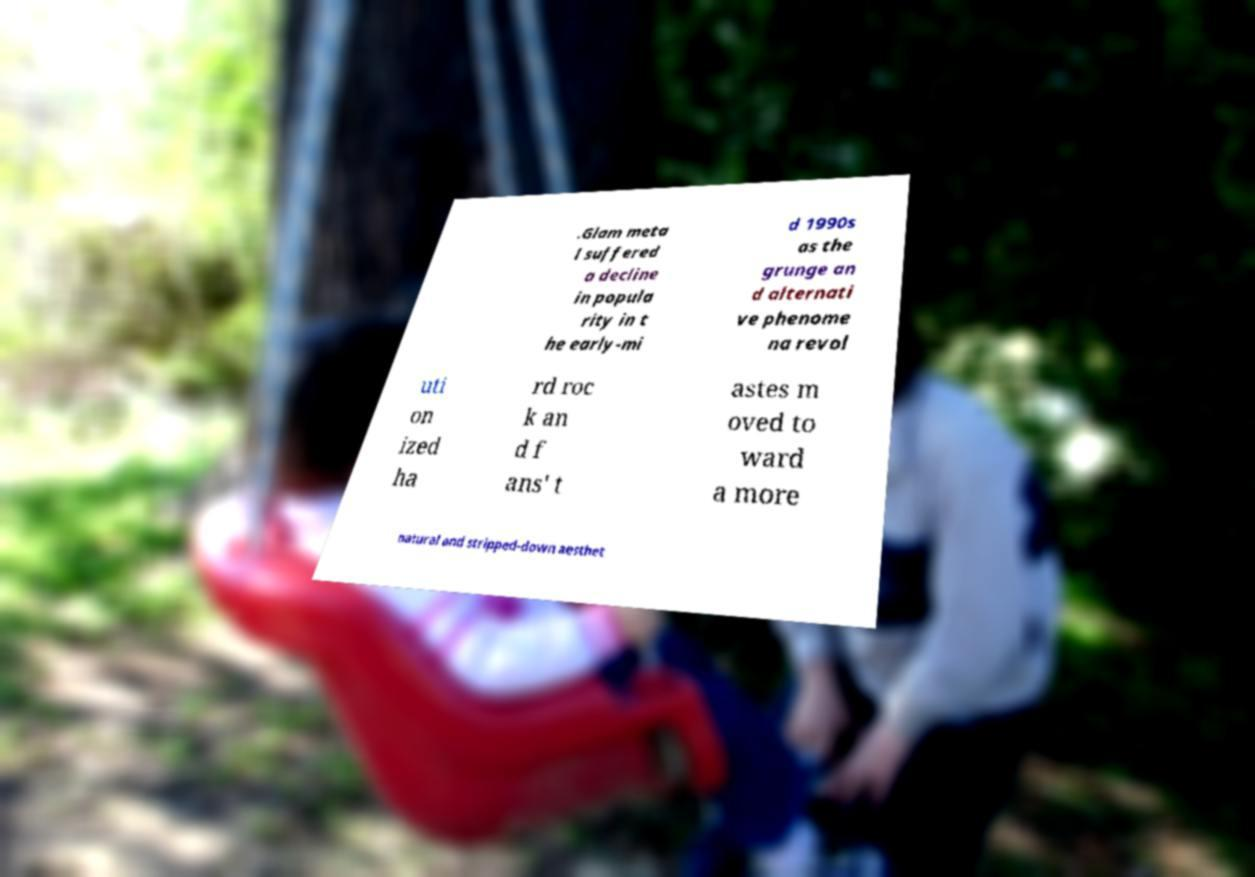There's text embedded in this image that I need extracted. Can you transcribe it verbatim? .Glam meta l suffered a decline in popula rity in t he early-mi d 1990s as the grunge an d alternati ve phenome na revol uti on ized ha rd roc k an d f ans' t astes m oved to ward a more natural and stripped-down aesthet 